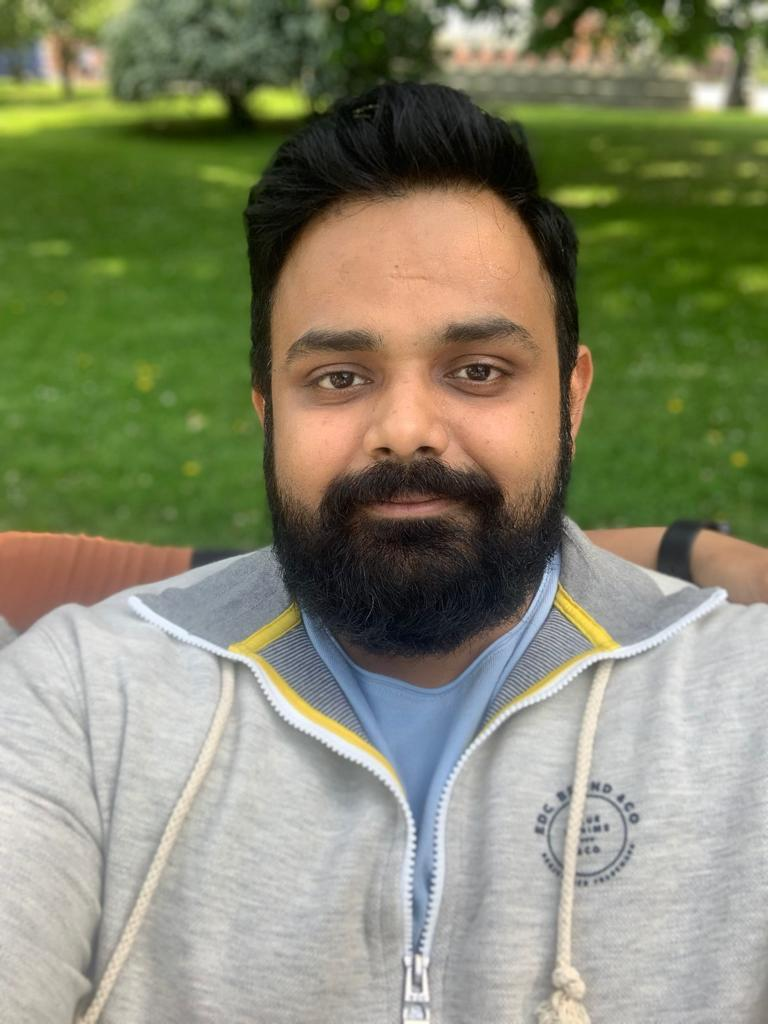which is the best beard type for this type of face? Choosing the best beard style often depends on individual preference, face shape, and how the beard grows. This person has a well-defined jawline and a full beard that appears to be evenly grown. This type of facial hair can support various beard styles successfully.

A full beard, as he currently has, suits his face quite well, complementing the shape and providing a balanced look. To enhance the appearance, maintaining the beard with regular trimming to keep it neat and shaped can be beneficial. If he wants to try something different, he could consider a shorter boxed beard, which would maintain the structure while presenting a more groomed appearance.

Alternatively, if he prefers a more defined look, he might go for a style that accentuates his jawline, such as a Van Dyke beard, which combines a mustache with a goatee, leaving the cheeks clean-shaven but maintaining prominence around the chin and mouth.

Ultimately, the best beard style is one that he feels comfortable with and that reflects his personal style while taking into consideration the natural growth pattern of his beard. Regular maintenance and grooming are key to any beard style looking its best. 